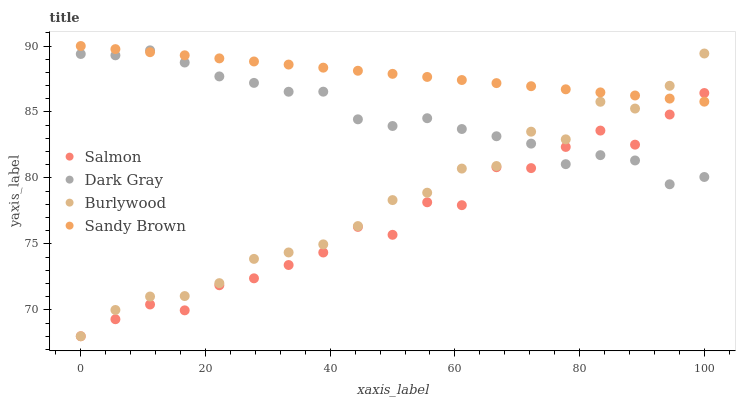Does Salmon have the minimum area under the curve?
Answer yes or no. Yes. Does Sandy Brown have the maximum area under the curve?
Answer yes or no. Yes. Does Burlywood have the minimum area under the curve?
Answer yes or no. No. Does Burlywood have the maximum area under the curve?
Answer yes or no. No. Is Sandy Brown the smoothest?
Answer yes or no. Yes. Is Salmon the roughest?
Answer yes or no. Yes. Is Burlywood the smoothest?
Answer yes or no. No. Is Burlywood the roughest?
Answer yes or no. No. Does Burlywood have the lowest value?
Answer yes or no. Yes. Does Sandy Brown have the lowest value?
Answer yes or no. No. Does Sandy Brown have the highest value?
Answer yes or no. Yes. Does Burlywood have the highest value?
Answer yes or no. No. Does Sandy Brown intersect Burlywood?
Answer yes or no. Yes. Is Sandy Brown less than Burlywood?
Answer yes or no. No. Is Sandy Brown greater than Burlywood?
Answer yes or no. No. 